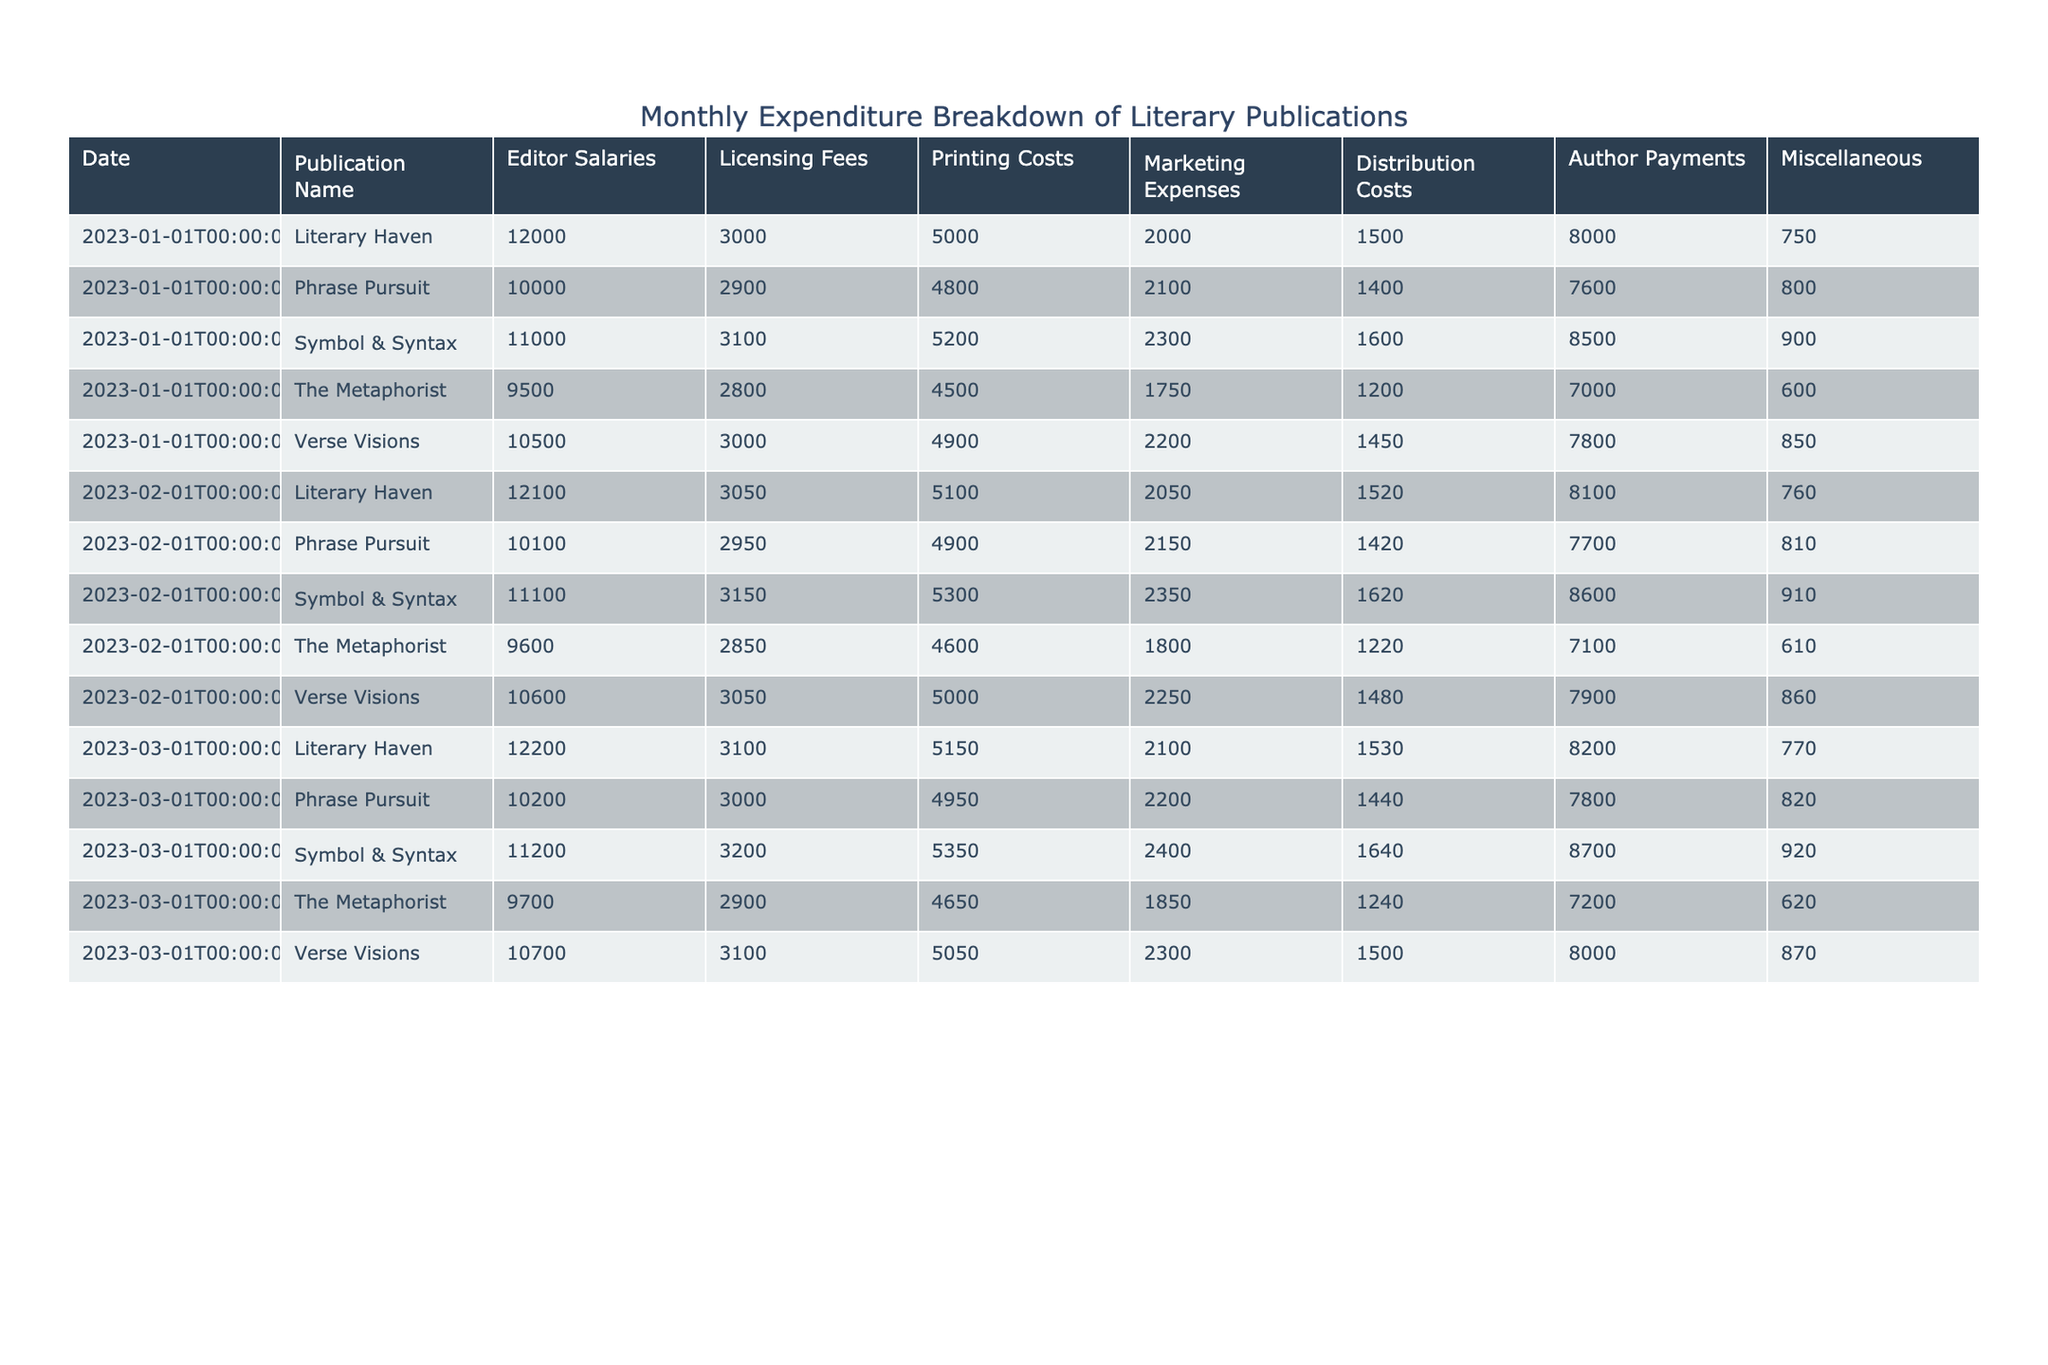What is the editor salary for "The Metaphorist" in March 2023? The table lists the editor salary for "The Metaphorist" under the March 2023 row, showing a value of 9700.
Answer: 9700 Which publication had the highest marketing expenses in February 2023? By checking the marketing expenses for each publication in February 2023, "Symbol & Syntax" has the highest value of 2350, compared to other publications listed.
Answer: Symbol & Syntax What are the total printing costs for "Literary Haven" from January to March 2023? The printing costs for "Literary Haven" in the three months are: 5000 (January), 5100 (February), and 5150 (March). Adding them up gives us 5000 + 5100 + 5150 = 15250.
Answer: 15250 Did "Phrase Pursuit" incur more than 7000 in author payments for any month in 2023? Looking at the author payments in the table for "Phrase Pursuit", the values are: 7600 in January, 7700 in February, and 7800 in March. All of these values are greater than 7000, therefore the answer is yes.
Answer: Yes What is the average distribution cost for "Verse Visions" over the first quarter of 2023? The distribution costs for "Verse Visions" are 1450 (January), 1480 (February), and 1500 (March). Adding these gives us 1450 + 1480 + 1500 = 4420. Dividing by the number of months (3) gives us an average of 4420 / 3 = approximately 1473.33.
Answer: 1473.33 Which publication had the lowest miscellaneous expenses in January 2023? By examining the miscellaneous expenses for each publication in January, "The Metaphorist" has the value of 600, which is the lowest among the listed publications for that month.
Answer: The Metaphorist How do the licensing fees of "Symbol & Syntax" change from January to March 2023? The licensing fees for "Symbol & Syntax" are 3100 in January, 3150 in February, and 3200 in March. This shows a consistent increase of 50 in fees each month.
Answer: They increase by 50 each month What publication has the highest total expenditure in March 2023? To determine this, we need to sum up all the expenditures for each publication in March 2023. The totals are: "Literary Haven" = 12200 + 3100 + 5150 + 2100 + 1530 + 8200 + 770, which equals 23900; "The Metaphorist" = 9700 + 2900 + 4650 + 1850 + 1240 + 7200 + 620 = 18760; "Symbol & Syntax" = 11200 + 3200 + 5350 + 2400 + 1640 + 8700 + 920 = 26310; "Phrase Pursuit" = 10200 + 3000 + 4950 + 2200 + 1440 + 7800 + 820 = 25900; "Verse Visions" = 10700 + 3100 + 5050 + 2300 + 1500 + 8000 + 870 = 30120. Therefore, "Verse Visions" has the highest total expenditure in March.
Answer: Verse Visions 